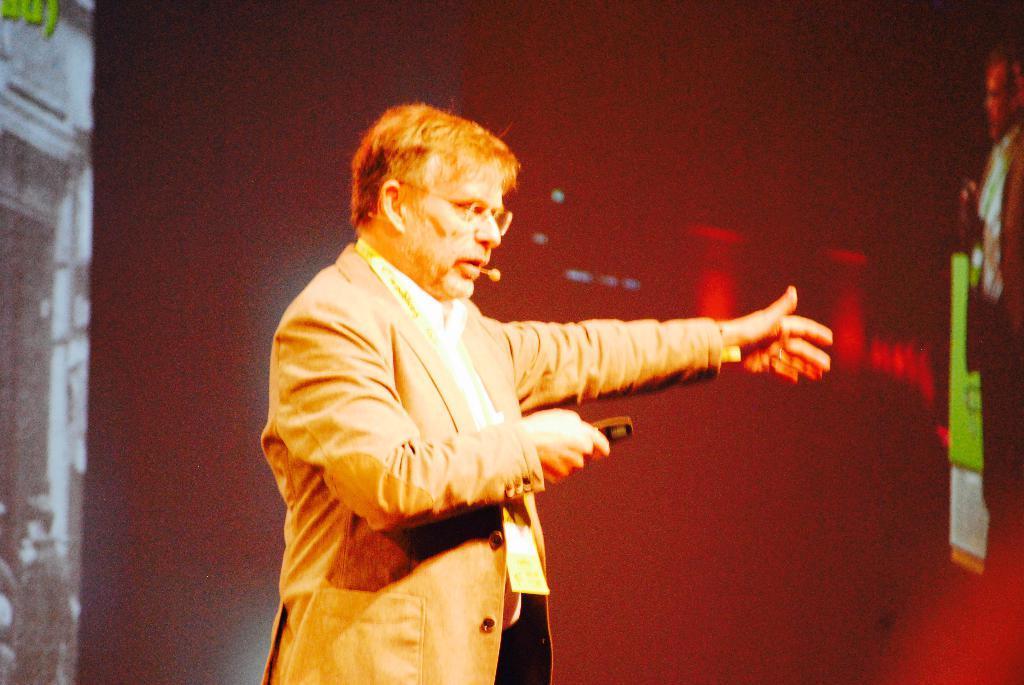Describe this image in one or two sentences. In this picture we can see a person holding a remote in his hand and wearing a microphone on his ear. We can see this man is talking. There are a few lights and other objects. 